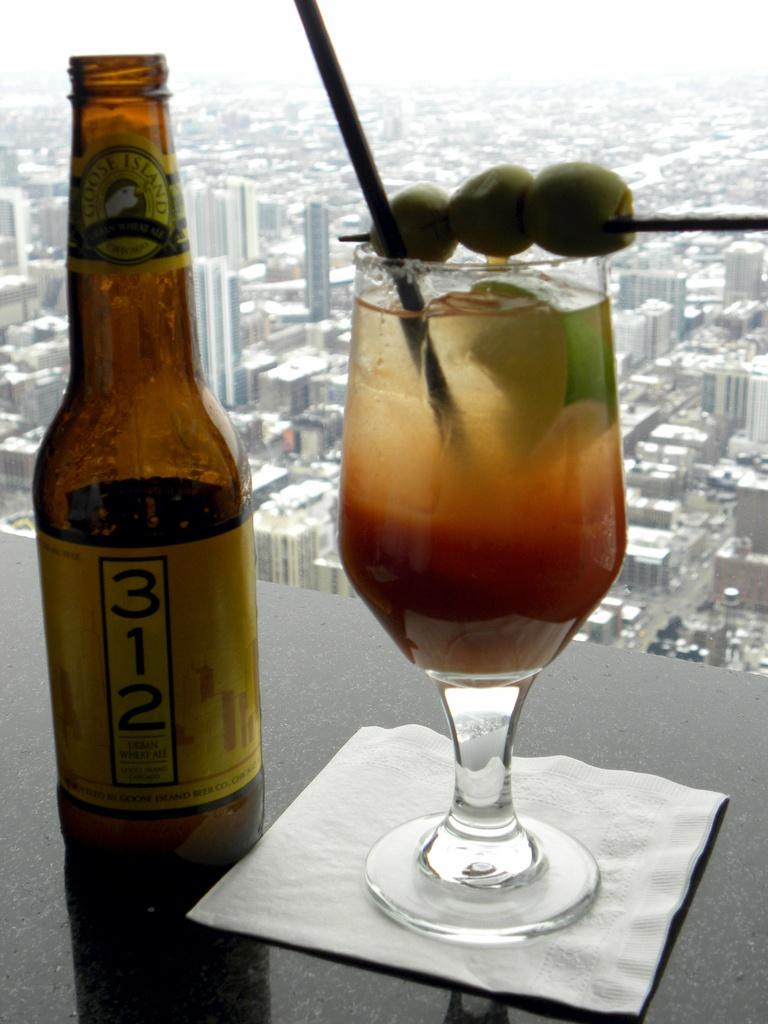<image>
Create a compact narrative representing the image presented. A brown bottle of beer says 312 and is next to a martini glass in a window sill above a city. 